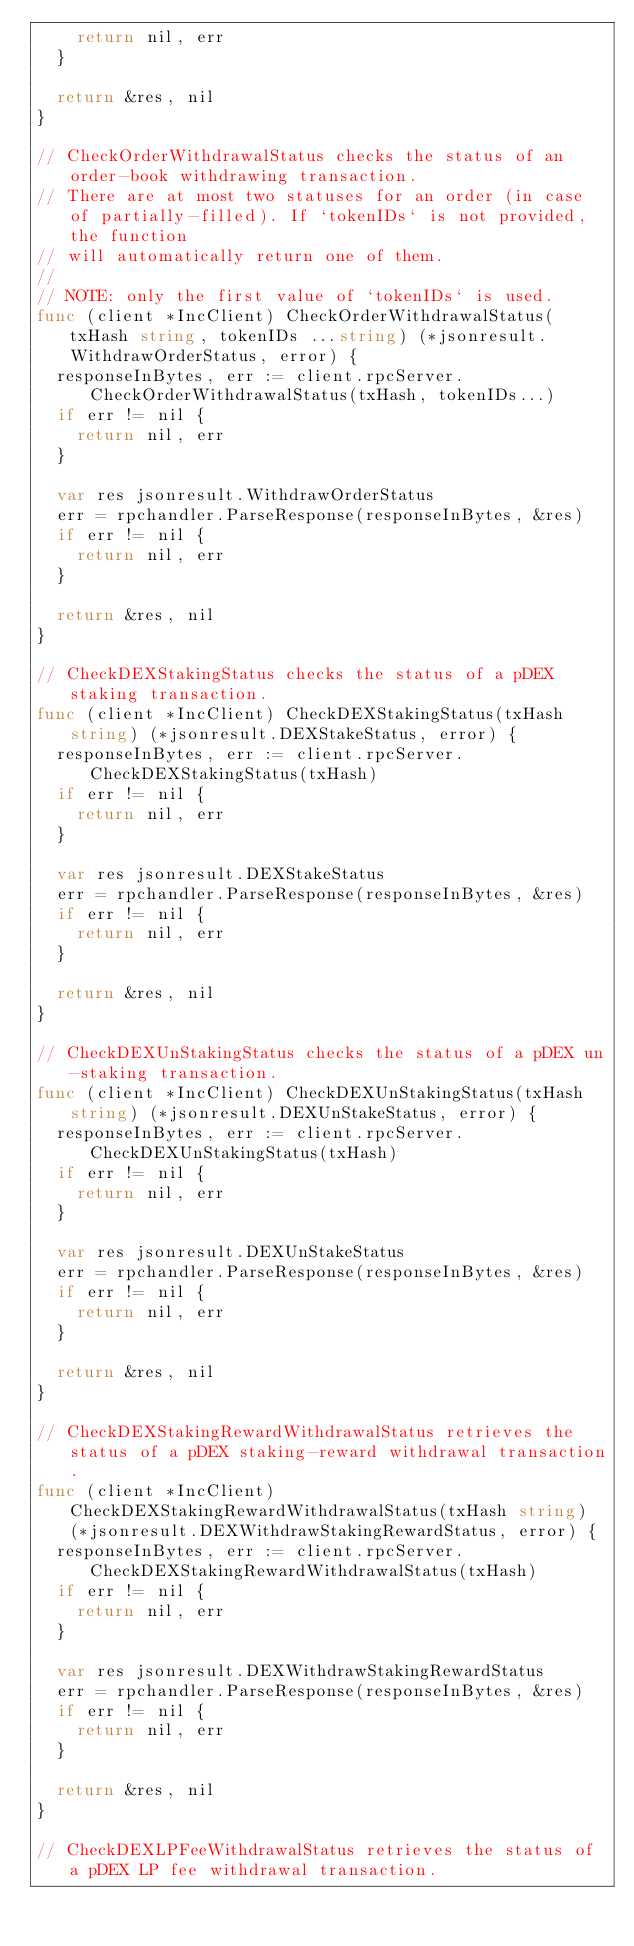Convert code to text. <code><loc_0><loc_0><loc_500><loc_500><_Go_>		return nil, err
	}

	return &res, nil
}

// CheckOrderWithdrawalStatus checks the status of an order-book withdrawing transaction.
// There are at most two statuses for an order (in case of partially-filled). If `tokenIDs` is not provided, the function
// will automatically return one of them.
//
// NOTE: only the first value of `tokenIDs` is used.
func (client *IncClient) CheckOrderWithdrawalStatus(txHash string, tokenIDs ...string) (*jsonresult.WithdrawOrderStatus, error) {
	responseInBytes, err := client.rpcServer.CheckOrderWithdrawalStatus(txHash, tokenIDs...)
	if err != nil {
		return nil, err
	}

	var res jsonresult.WithdrawOrderStatus
	err = rpchandler.ParseResponse(responseInBytes, &res)
	if err != nil {
		return nil, err
	}

	return &res, nil
}

// CheckDEXStakingStatus checks the status of a pDEX staking transaction.
func (client *IncClient) CheckDEXStakingStatus(txHash string) (*jsonresult.DEXStakeStatus, error) {
	responseInBytes, err := client.rpcServer.CheckDEXStakingStatus(txHash)
	if err != nil {
		return nil, err
	}

	var res jsonresult.DEXStakeStatus
	err = rpchandler.ParseResponse(responseInBytes, &res)
	if err != nil {
		return nil, err
	}

	return &res, nil
}

// CheckDEXUnStakingStatus checks the status of a pDEX un-staking transaction.
func (client *IncClient) CheckDEXUnStakingStatus(txHash string) (*jsonresult.DEXUnStakeStatus, error) {
	responseInBytes, err := client.rpcServer.CheckDEXUnStakingStatus(txHash)
	if err != nil {
		return nil, err
	}

	var res jsonresult.DEXUnStakeStatus
	err = rpchandler.ParseResponse(responseInBytes, &res)
	if err != nil {
		return nil, err
	}

	return &res, nil
}

// CheckDEXStakingRewardWithdrawalStatus retrieves the status of a pDEX staking-reward withdrawal transaction.
func (client *IncClient) CheckDEXStakingRewardWithdrawalStatus(txHash string) (*jsonresult.DEXWithdrawStakingRewardStatus, error) {
	responseInBytes, err := client.rpcServer.CheckDEXStakingRewardWithdrawalStatus(txHash)
	if err != nil {
		return nil, err
	}

	var res jsonresult.DEXWithdrawStakingRewardStatus
	err = rpchandler.ParseResponse(responseInBytes, &res)
	if err != nil {
		return nil, err
	}

	return &res, nil
}

// CheckDEXLPFeeWithdrawalStatus retrieves the status of a pDEX LP fee withdrawal transaction.</code> 